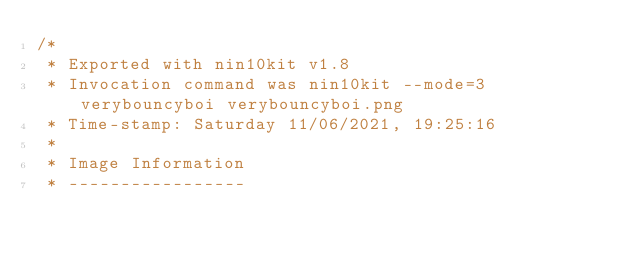<code> <loc_0><loc_0><loc_500><loc_500><_C_>/*
 * Exported with nin10kit v1.8
 * Invocation command was nin10kit --mode=3 verybouncyboi verybouncyboi.png 
 * Time-stamp: Saturday 11/06/2021, 19:25:16
 * 
 * Image Information
 * -----------------</code> 